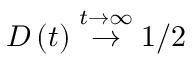<formula> <loc_0><loc_0><loc_500><loc_500>D \left ( t \right ) \stackrel { t \rightarrow \infty } { \rightarrow } 1 / 2</formula> 